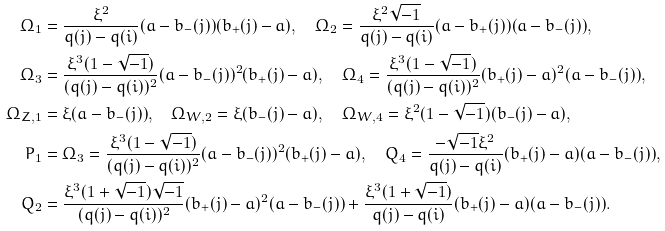Convert formula to latex. <formula><loc_0><loc_0><loc_500><loc_500>\Omega _ { 1 } & = \frac { \xi ^ { 2 } } { q ( j ) - q ( i ) } ( a - b _ { - } ( j ) ) ( b _ { + } ( j ) - a ) , \quad \Omega _ { 2 } = \frac { \xi ^ { 2 } \sqrt { - 1 } } { q ( j ) - q ( i ) } ( a - b _ { + } ( j ) ) ( a - b _ { - } ( j ) ) , \\ \Omega _ { 3 } & = \frac { \xi ^ { 3 } ( 1 - \sqrt { - 1 } ) } { ( q ( j ) - q ( i ) ) ^ { 2 } } ( a - b _ { - } ( j ) ) ^ { 2 } ( b _ { + } ( j ) - a ) , \quad \Omega _ { 4 } = \frac { \xi ^ { 3 } ( 1 - \sqrt { - 1 } ) } { ( q ( j ) - q ( i ) ) ^ { 2 } } ( b _ { + } ( j ) - a ) ^ { 2 } ( a - b _ { - } ( j ) ) , \\ \Omega _ { Z , 1 } & = \xi ( a - b _ { - } ( j ) ) , \quad \Omega _ { W , 2 } = \xi ( b _ { - } ( j ) - a ) , \quad \Omega _ { W , 4 } = \xi ^ { 2 } ( 1 - \sqrt { - 1 } ) ( b _ { - } ( j ) - a ) , \\ P _ { 1 } & = \Omega _ { 3 } = \frac { \xi ^ { 3 } ( 1 - \sqrt { - 1 } ) } { ( q ( j ) - q ( i ) ) ^ { 2 } } ( a - b _ { - } ( j ) ) ^ { 2 } ( b _ { + } ( j ) - a ) , \quad Q _ { 4 } = \frac { - \sqrt { - 1 } \xi ^ { 2 } } { q ( j ) - q ( i ) } ( b _ { + } ( j ) - a ) ( a - b _ { - } ( j ) ) , \\ Q _ { 2 } & = \frac { \xi ^ { 3 } ( 1 + \sqrt { - 1 } ) \sqrt { - 1 } } { ( q ( j ) - q ( i ) ) ^ { 2 } } ( b _ { + } ( j ) - a ) ^ { 2 } ( a - b _ { - } ( j ) ) + \frac { \xi ^ { 3 } ( 1 + \sqrt { - 1 } ) } { q ( j ) - q ( i ) } ( b _ { + } ( j ) - a ) ( a - b _ { - } ( j ) ) .</formula> 